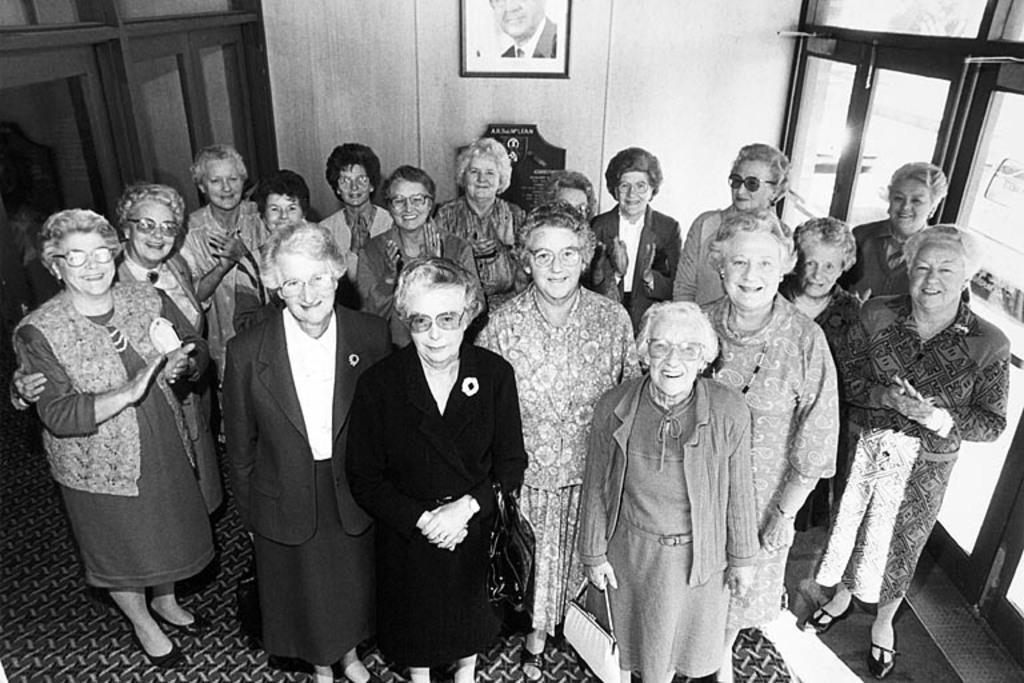Describe this image in one or two sentences. In this black and white picture there are women standing. They are smiling. Behind them there is a wall. There is a picture frame hanging on the wall. On the either sides of the image there are glass walls. At the bottom there is a carpet on the floor. 